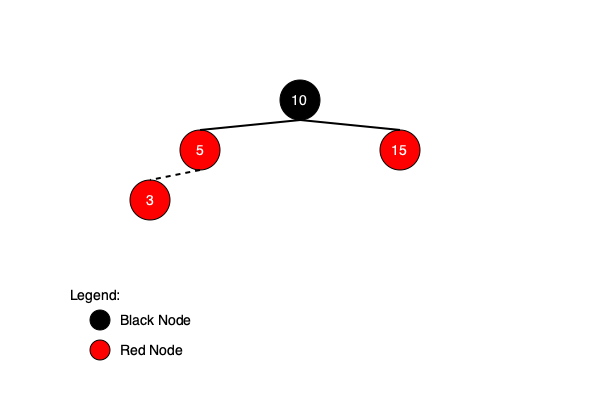Consider the red-black tree shown in the diagram. If we insert a new node with value 3, what color should it be, and what recoloring or rotations (if any) are necessary to maintain the red-black tree properties? Let's analyze this step-by-step:

1. Initial insertion: The new node with value 3 is inserted as a red node (as per red-black tree rules) as the left child of node 5.

2. Property check:
   - The root is black (✓)
   - Every leaf (NULL) is black (✓)
   - If a node is red, both its children are black (✗ violated at node 5)
   - Every path from a node to its descendant leaves contains the same number of black nodes (✓)

3. Violation handling:
   - The new node (3) and its parent (5) are both red, violating the red-black property.
   - The uncle of node 3 (node 15) is red.

4. Recoloring:
   - In this case, we perform recoloring:
     a. Color the parent (5) black
     b. Color the uncle (15) black
     c. Color the grandparent (10) red

5. Final check:
   - After recoloring, we need to check if the grandparent's new red color violates any property with its parent.
   - In this case, the grandparent (10) is the root, so we color it black to maintain the root property.

6. Result:
   - Node 3: Red
   - Node 5: Black
   - Node 10 (root): Black
   - Node 15: Black

No rotations are necessary in this case, only recoloring.
Answer: Red; Recolor nodes 5 and 15 to black, 10 to red, then black (root). 